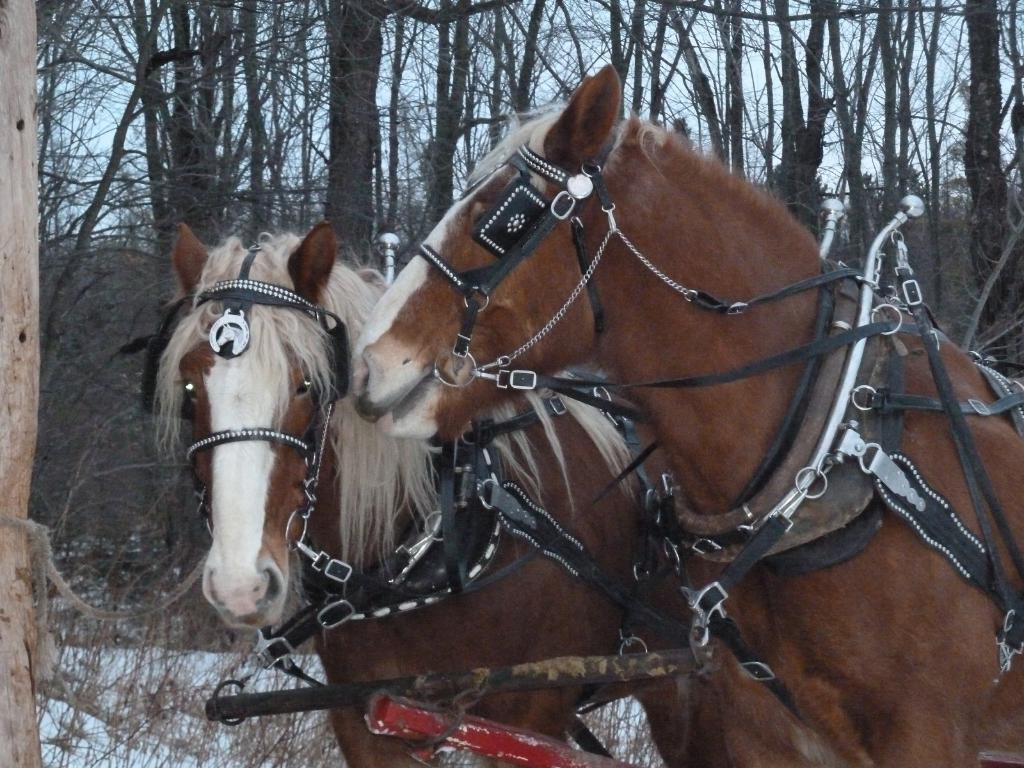What animals are present in the image? There are horses in the image. What is unique about the horses in the image? The horses have belts on them. What can be seen in the background of the image? There are trees and the sky visible in the background of the image. What type of cup is being used by the horses in the image? There is no cup present in the image; the horses have belts on them. How does the tongue of the horse interact with the belt in the image? There is no interaction between the horse's tongue and the belt in the image, as the horses have belts on them but no tongues are visible. 